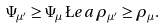Convert formula to latex. <formula><loc_0><loc_0><loc_500><loc_500>\Psi _ { \mu ^ { \prime } } \geq \Psi _ { \mu } \, \L e a \, \rho _ { \mu ^ { \prime } } \geq \rho _ { \mu } .</formula> 